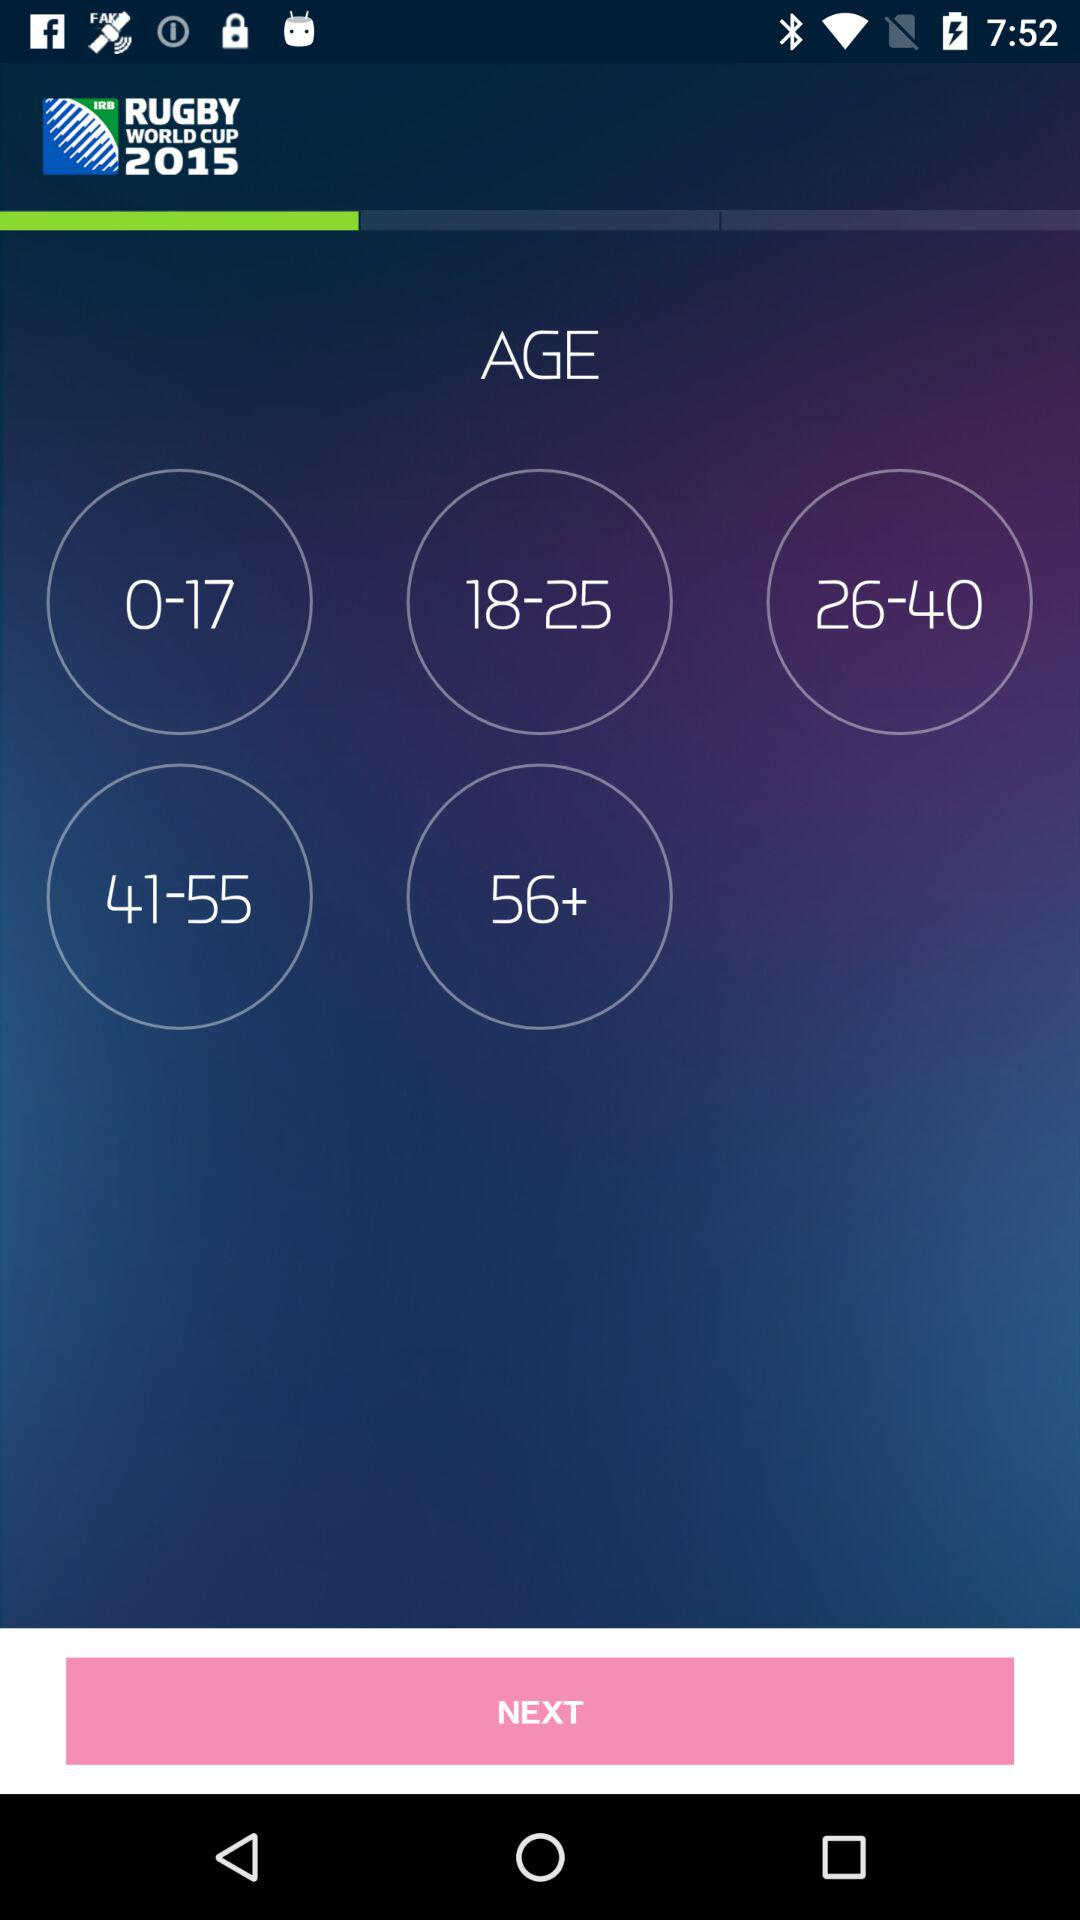What are the available options? The available options are "0-17", "18-25", "26-40", "41-55" and "56+". 